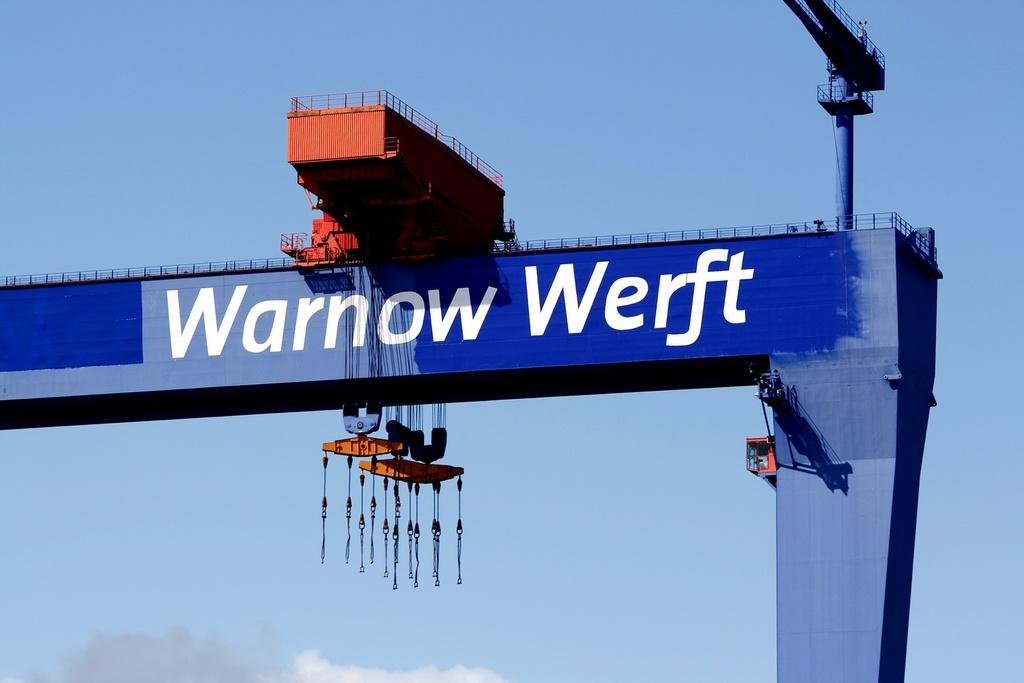<image>
Summarize the visual content of the image. A large device says Warnow Werft on the side. 